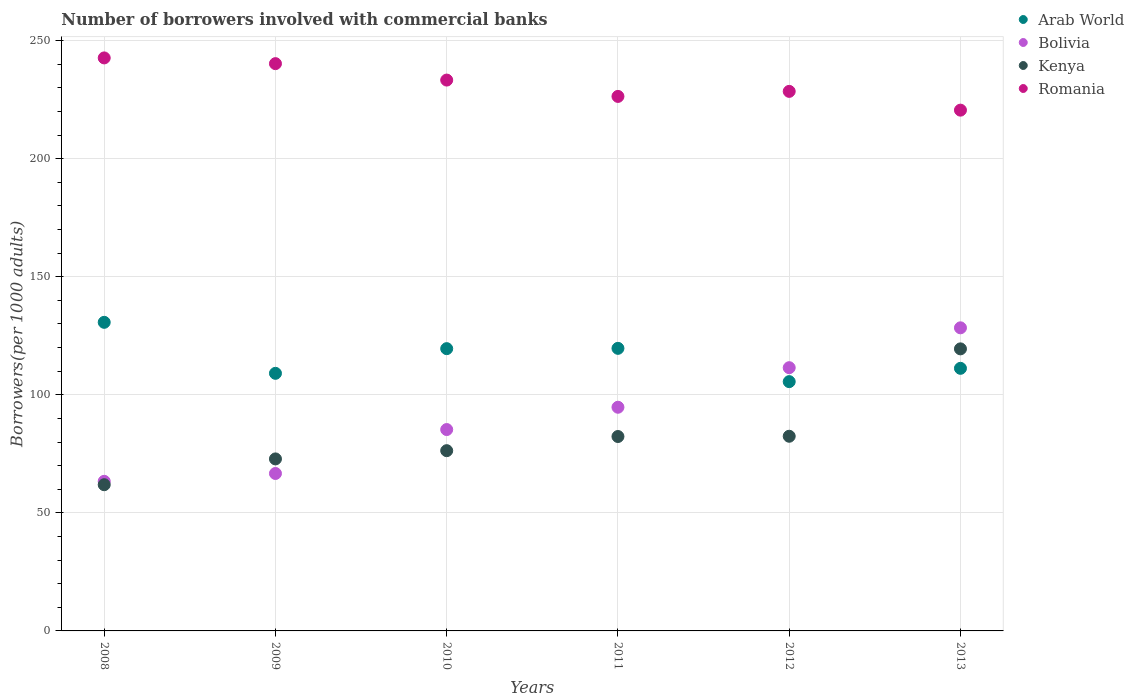How many different coloured dotlines are there?
Ensure brevity in your answer.  4. What is the number of borrowers involved with commercial banks in Arab World in 2009?
Give a very brief answer. 109.1. Across all years, what is the maximum number of borrowers involved with commercial banks in Romania?
Provide a short and direct response. 242.68. Across all years, what is the minimum number of borrowers involved with commercial banks in Romania?
Your answer should be compact. 220.56. What is the total number of borrowers involved with commercial banks in Arab World in the graph?
Offer a terse response. 695.82. What is the difference between the number of borrowers involved with commercial banks in Romania in 2010 and that in 2012?
Ensure brevity in your answer.  4.79. What is the difference between the number of borrowers involved with commercial banks in Kenya in 2011 and the number of borrowers involved with commercial banks in Romania in 2012?
Your response must be concise. -146.17. What is the average number of borrowers involved with commercial banks in Bolivia per year?
Provide a succinct answer. 91.65. In the year 2008, what is the difference between the number of borrowers involved with commercial banks in Bolivia and number of borrowers involved with commercial banks in Arab World?
Your answer should be very brief. -67.34. In how many years, is the number of borrowers involved with commercial banks in Bolivia greater than 220?
Your response must be concise. 0. What is the ratio of the number of borrowers involved with commercial banks in Bolivia in 2008 to that in 2010?
Give a very brief answer. 0.74. Is the number of borrowers involved with commercial banks in Bolivia in 2010 less than that in 2013?
Your answer should be compact. Yes. Is the difference between the number of borrowers involved with commercial banks in Bolivia in 2008 and 2013 greater than the difference between the number of borrowers involved with commercial banks in Arab World in 2008 and 2013?
Your response must be concise. No. What is the difference between the highest and the second highest number of borrowers involved with commercial banks in Bolivia?
Provide a short and direct response. 16.88. What is the difference between the highest and the lowest number of borrowers involved with commercial banks in Romania?
Your answer should be very brief. 22.12. Is it the case that in every year, the sum of the number of borrowers involved with commercial banks in Romania and number of borrowers involved with commercial banks in Bolivia  is greater than the number of borrowers involved with commercial banks in Kenya?
Offer a very short reply. Yes. Does the number of borrowers involved with commercial banks in Kenya monotonically increase over the years?
Your response must be concise. Yes. How many dotlines are there?
Your answer should be very brief. 4. Are the values on the major ticks of Y-axis written in scientific E-notation?
Provide a short and direct response. No. What is the title of the graph?
Provide a succinct answer. Number of borrowers involved with commercial banks. What is the label or title of the Y-axis?
Your response must be concise. Borrowers(per 1000 adults). What is the Borrowers(per 1000 adults) in Arab World in 2008?
Offer a terse response. 130.7. What is the Borrowers(per 1000 adults) in Bolivia in 2008?
Offer a terse response. 63.36. What is the Borrowers(per 1000 adults) of Kenya in 2008?
Provide a succinct answer. 61.92. What is the Borrowers(per 1000 adults) of Romania in 2008?
Make the answer very short. 242.68. What is the Borrowers(per 1000 adults) of Arab World in 2009?
Offer a terse response. 109.1. What is the Borrowers(per 1000 adults) in Bolivia in 2009?
Keep it short and to the point. 66.68. What is the Borrowers(per 1000 adults) of Kenya in 2009?
Provide a short and direct response. 72.85. What is the Borrowers(per 1000 adults) of Romania in 2009?
Your response must be concise. 240.26. What is the Borrowers(per 1000 adults) of Arab World in 2010?
Ensure brevity in your answer.  119.55. What is the Borrowers(per 1000 adults) in Bolivia in 2010?
Your answer should be very brief. 85.29. What is the Borrowers(per 1000 adults) of Kenya in 2010?
Offer a terse response. 76.34. What is the Borrowers(per 1000 adults) of Romania in 2010?
Offer a terse response. 233.3. What is the Borrowers(per 1000 adults) in Arab World in 2011?
Offer a terse response. 119.68. What is the Borrowers(per 1000 adults) in Bolivia in 2011?
Your answer should be very brief. 94.73. What is the Borrowers(per 1000 adults) of Kenya in 2011?
Keep it short and to the point. 82.34. What is the Borrowers(per 1000 adults) in Romania in 2011?
Your answer should be very brief. 226.38. What is the Borrowers(per 1000 adults) in Arab World in 2012?
Keep it short and to the point. 105.58. What is the Borrowers(per 1000 adults) of Bolivia in 2012?
Give a very brief answer. 111.49. What is the Borrowers(per 1000 adults) in Kenya in 2012?
Offer a terse response. 82.45. What is the Borrowers(per 1000 adults) in Romania in 2012?
Make the answer very short. 228.51. What is the Borrowers(per 1000 adults) of Arab World in 2013?
Ensure brevity in your answer.  111.22. What is the Borrowers(per 1000 adults) in Bolivia in 2013?
Provide a short and direct response. 128.37. What is the Borrowers(per 1000 adults) of Kenya in 2013?
Offer a very short reply. 119.46. What is the Borrowers(per 1000 adults) of Romania in 2013?
Your response must be concise. 220.56. Across all years, what is the maximum Borrowers(per 1000 adults) in Arab World?
Your answer should be very brief. 130.7. Across all years, what is the maximum Borrowers(per 1000 adults) in Bolivia?
Your answer should be compact. 128.37. Across all years, what is the maximum Borrowers(per 1000 adults) of Kenya?
Keep it short and to the point. 119.46. Across all years, what is the maximum Borrowers(per 1000 adults) of Romania?
Provide a succinct answer. 242.68. Across all years, what is the minimum Borrowers(per 1000 adults) in Arab World?
Your answer should be very brief. 105.58. Across all years, what is the minimum Borrowers(per 1000 adults) in Bolivia?
Your response must be concise. 63.36. Across all years, what is the minimum Borrowers(per 1000 adults) in Kenya?
Your answer should be compact. 61.92. Across all years, what is the minimum Borrowers(per 1000 adults) in Romania?
Your answer should be compact. 220.56. What is the total Borrowers(per 1000 adults) of Arab World in the graph?
Provide a short and direct response. 695.82. What is the total Borrowers(per 1000 adults) in Bolivia in the graph?
Provide a succinct answer. 549.91. What is the total Borrowers(per 1000 adults) in Kenya in the graph?
Make the answer very short. 495.36. What is the total Borrowers(per 1000 adults) of Romania in the graph?
Offer a terse response. 1391.7. What is the difference between the Borrowers(per 1000 adults) in Arab World in 2008 and that in 2009?
Your response must be concise. 21.6. What is the difference between the Borrowers(per 1000 adults) in Bolivia in 2008 and that in 2009?
Make the answer very short. -3.32. What is the difference between the Borrowers(per 1000 adults) of Kenya in 2008 and that in 2009?
Offer a very short reply. -10.93. What is the difference between the Borrowers(per 1000 adults) of Romania in 2008 and that in 2009?
Keep it short and to the point. 2.43. What is the difference between the Borrowers(per 1000 adults) in Arab World in 2008 and that in 2010?
Your answer should be very brief. 11.15. What is the difference between the Borrowers(per 1000 adults) of Bolivia in 2008 and that in 2010?
Ensure brevity in your answer.  -21.93. What is the difference between the Borrowers(per 1000 adults) of Kenya in 2008 and that in 2010?
Provide a succinct answer. -14.42. What is the difference between the Borrowers(per 1000 adults) of Romania in 2008 and that in 2010?
Your answer should be very brief. 9.38. What is the difference between the Borrowers(per 1000 adults) in Arab World in 2008 and that in 2011?
Offer a very short reply. 11.02. What is the difference between the Borrowers(per 1000 adults) in Bolivia in 2008 and that in 2011?
Offer a terse response. -31.37. What is the difference between the Borrowers(per 1000 adults) of Kenya in 2008 and that in 2011?
Provide a succinct answer. -20.41. What is the difference between the Borrowers(per 1000 adults) of Romania in 2008 and that in 2011?
Your answer should be very brief. 16.31. What is the difference between the Borrowers(per 1000 adults) of Arab World in 2008 and that in 2012?
Ensure brevity in your answer.  25.12. What is the difference between the Borrowers(per 1000 adults) in Bolivia in 2008 and that in 2012?
Offer a terse response. -48.13. What is the difference between the Borrowers(per 1000 adults) in Kenya in 2008 and that in 2012?
Provide a short and direct response. -20.52. What is the difference between the Borrowers(per 1000 adults) of Romania in 2008 and that in 2012?
Your answer should be very brief. 14.17. What is the difference between the Borrowers(per 1000 adults) in Arab World in 2008 and that in 2013?
Your answer should be compact. 19.48. What is the difference between the Borrowers(per 1000 adults) in Bolivia in 2008 and that in 2013?
Give a very brief answer. -65.01. What is the difference between the Borrowers(per 1000 adults) in Kenya in 2008 and that in 2013?
Your response must be concise. -57.54. What is the difference between the Borrowers(per 1000 adults) of Romania in 2008 and that in 2013?
Offer a very short reply. 22.12. What is the difference between the Borrowers(per 1000 adults) in Arab World in 2009 and that in 2010?
Your response must be concise. -10.45. What is the difference between the Borrowers(per 1000 adults) in Bolivia in 2009 and that in 2010?
Provide a short and direct response. -18.61. What is the difference between the Borrowers(per 1000 adults) of Kenya in 2009 and that in 2010?
Provide a succinct answer. -3.49. What is the difference between the Borrowers(per 1000 adults) of Romania in 2009 and that in 2010?
Your answer should be compact. 6.96. What is the difference between the Borrowers(per 1000 adults) of Arab World in 2009 and that in 2011?
Offer a very short reply. -10.58. What is the difference between the Borrowers(per 1000 adults) in Bolivia in 2009 and that in 2011?
Your response must be concise. -28.05. What is the difference between the Borrowers(per 1000 adults) of Kenya in 2009 and that in 2011?
Provide a succinct answer. -9.49. What is the difference between the Borrowers(per 1000 adults) in Romania in 2009 and that in 2011?
Your response must be concise. 13.88. What is the difference between the Borrowers(per 1000 adults) in Arab World in 2009 and that in 2012?
Provide a succinct answer. 3.52. What is the difference between the Borrowers(per 1000 adults) of Bolivia in 2009 and that in 2012?
Give a very brief answer. -44.81. What is the difference between the Borrowers(per 1000 adults) in Kenya in 2009 and that in 2012?
Ensure brevity in your answer.  -9.6. What is the difference between the Borrowers(per 1000 adults) in Romania in 2009 and that in 2012?
Make the answer very short. 11.75. What is the difference between the Borrowers(per 1000 adults) in Arab World in 2009 and that in 2013?
Your answer should be compact. -2.12. What is the difference between the Borrowers(per 1000 adults) in Bolivia in 2009 and that in 2013?
Offer a terse response. -61.69. What is the difference between the Borrowers(per 1000 adults) of Kenya in 2009 and that in 2013?
Give a very brief answer. -46.61. What is the difference between the Borrowers(per 1000 adults) of Romania in 2009 and that in 2013?
Provide a succinct answer. 19.7. What is the difference between the Borrowers(per 1000 adults) in Arab World in 2010 and that in 2011?
Keep it short and to the point. -0.13. What is the difference between the Borrowers(per 1000 adults) in Bolivia in 2010 and that in 2011?
Offer a terse response. -9.45. What is the difference between the Borrowers(per 1000 adults) of Kenya in 2010 and that in 2011?
Make the answer very short. -6. What is the difference between the Borrowers(per 1000 adults) in Romania in 2010 and that in 2011?
Provide a succinct answer. 6.92. What is the difference between the Borrowers(per 1000 adults) of Arab World in 2010 and that in 2012?
Provide a succinct answer. 13.97. What is the difference between the Borrowers(per 1000 adults) in Bolivia in 2010 and that in 2012?
Make the answer very short. -26.2. What is the difference between the Borrowers(per 1000 adults) in Kenya in 2010 and that in 2012?
Provide a succinct answer. -6.11. What is the difference between the Borrowers(per 1000 adults) in Romania in 2010 and that in 2012?
Offer a very short reply. 4.79. What is the difference between the Borrowers(per 1000 adults) of Arab World in 2010 and that in 2013?
Make the answer very short. 8.33. What is the difference between the Borrowers(per 1000 adults) in Bolivia in 2010 and that in 2013?
Provide a short and direct response. -43.08. What is the difference between the Borrowers(per 1000 adults) in Kenya in 2010 and that in 2013?
Your answer should be compact. -43.12. What is the difference between the Borrowers(per 1000 adults) of Romania in 2010 and that in 2013?
Give a very brief answer. 12.74. What is the difference between the Borrowers(per 1000 adults) of Arab World in 2011 and that in 2012?
Provide a short and direct response. 14.1. What is the difference between the Borrowers(per 1000 adults) of Bolivia in 2011 and that in 2012?
Make the answer very short. -16.75. What is the difference between the Borrowers(per 1000 adults) in Kenya in 2011 and that in 2012?
Provide a short and direct response. -0.11. What is the difference between the Borrowers(per 1000 adults) of Romania in 2011 and that in 2012?
Keep it short and to the point. -2.13. What is the difference between the Borrowers(per 1000 adults) in Arab World in 2011 and that in 2013?
Ensure brevity in your answer.  8.46. What is the difference between the Borrowers(per 1000 adults) in Bolivia in 2011 and that in 2013?
Offer a very short reply. -33.64. What is the difference between the Borrowers(per 1000 adults) in Kenya in 2011 and that in 2013?
Offer a terse response. -37.12. What is the difference between the Borrowers(per 1000 adults) in Romania in 2011 and that in 2013?
Give a very brief answer. 5.82. What is the difference between the Borrowers(per 1000 adults) of Arab World in 2012 and that in 2013?
Make the answer very short. -5.64. What is the difference between the Borrowers(per 1000 adults) of Bolivia in 2012 and that in 2013?
Your answer should be very brief. -16.88. What is the difference between the Borrowers(per 1000 adults) of Kenya in 2012 and that in 2013?
Make the answer very short. -37.01. What is the difference between the Borrowers(per 1000 adults) of Romania in 2012 and that in 2013?
Provide a short and direct response. 7.95. What is the difference between the Borrowers(per 1000 adults) of Arab World in 2008 and the Borrowers(per 1000 adults) of Bolivia in 2009?
Your answer should be very brief. 64.02. What is the difference between the Borrowers(per 1000 adults) in Arab World in 2008 and the Borrowers(per 1000 adults) in Kenya in 2009?
Ensure brevity in your answer.  57.85. What is the difference between the Borrowers(per 1000 adults) in Arab World in 2008 and the Borrowers(per 1000 adults) in Romania in 2009?
Provide a short and direct response. -109.56. What is the difference between the Borrowers(per 1000 adults) of Bolivia in 2008 and the Borrowers(per 1000 adults) of Kenya in 2009?
Your response must be concise. -9.49. What is the difference between the Borrowers(per 1000 adults) in Bolivia in 2008 and the Borrowers(per 1000 adults) in Romania in 2009?
Provide a succinct answer. -176.9. What is the difference between the Borrowers(per 1000 adults) of Kenya in 2008 and the Borrowers(per 1000 adults) of Romania in 2009?
Make the answer very short. -178.34. What is the difference between the Borrowers(per 1000 adults) of Arab World in 2008 and the Borrowers(per 1000 adults) of Bolivia in 2010?
Make the answer very short. 45.41. What is the difference between the Borrowers(per 1000 adults) of Arab World in 2008 and the Borrowers(per 1000 adults) of Kenya in 2010?
Make the answer very short. 54.36. What is the difference between the Borrowers(per 1000 adults) of Arab World in 2008 and the Borrowers(per 1000 adults) of Romania in 2010?
Provide a succinct answer. -102.6. What is the difference between the Borrowers(per 1000 adults) in Bolivia in 2008 and the Borrowers(per 1000 adults) in Kenya in 2010?
Provide a succinct answer. -12.98. What is the difference between the Borrowers(per 1000 adults) of Bolivia in 2008 and the Borrowers(per 1000 adults) of Romania in 2010?
Make the answer very short. -169.94. What is the difference between the Borrowers(per 1000 adults) of Kenya in 2008 and the Borrowers(per 1000 adults) of Romania in 2010?
Offer a very short reply. -171.38. What is the difference between the Borrowers(per 1000 adults) in Arab World in 2008 and the Borrowers(per 1000 adults) in Bolivia in 2011?
Offer a terse response. 35.97. What is the difference between the Borrowers(per 1000 adults) of Arab World in 2008 and the Borrowers(per 1000 adults) of Kenya in 2011?
Offer a terse response. 48.36. What is the difference between the Borrowers(per 1000 adults) of Arab World in 2008 and the Borrowers(per 1000 adults) of Romania in 2011?
Provide a succinct answer. -95.68. What is the difference between the Borrowers(per 1000 adults) in Bolivia in 2008 and the Borrowers(per 1000 adults) in Kenya in 2011?
Give a very brief answer. -18.98. What is the difference between the Borrowers(per 1000 adults) of Bolivia in 2008 and the Borrowers(per 1000 adults) of Romania in 2011?
Give a very brief answer. -163.02. What is the difference between the Borrowers(per 1000 adults) of Kenya in 2008 and the Borrowers(per 1000 adults) of Romania in 2011?
Offer a terse response. -164.46. What is the difference between the Borrowers(per 1000 adults) of Arab World in 2008 and the Borrowers(per 1000 adults) of Bolivia in 2012?
Ensure brevity in your answer.  19.21. What is the difference between the Borrowers(per 1000 adults) of Arab World in 2008 and the Borrowers(per 1000 adults) of Kenya in 2012?
Your answer should be compact. 48.25. What is the difference between the Borrowers(per 1000 adults) in Arab World in 2008 and the Borrowers(per 1000 adults) in Romania in 2012?
Your answer should be very brief. -97.81. What is the difference between the Borrowers(per 1000 adults) in Bolivia in 2008 and the Borrowers(per 1000 adults) in Kenya in 2012?
Provide a succinct answer. -19.09. What is the difference between the Borrowers(per 1000 adults) of Bolivia in 2008 and the Borrowers(per 1000 adults) of Romania in 2012?
Offer a terse response. -165.15. What is the difference between the Borrowers(per 1000 adults) in Kenya in 2008 and the Borrowers(per 1000 adults) in Romania in 2012?
Offer a very short reply. -166.59. What is the difference between the Borrowers(per 1000 adults) in Arab World in 2008 and the Borrowers(per 1000 adults) in Bolivia in 2013?
Ensure brevity in your answer.  2.33. What is the difference between the Borrowers(per 1000 adults) in Arab World in 2008 and the Borrowers(per 1000 adults) in Kenya in 2013?
Offer a terse response. 11.24. What is the difference between the Borrowers(per 1000 adults) in Arab World in 2008 and the Borrowers(per 1000 adults) in Romania in 2013?
Provide a succinct answer. -89.87. What is the difference between the Borrowers(per 1000 adults) in Bolivia in 2008 and the Borrowers(per 1000 adults) in Kenya in 2013?
Your answer should be very brief. -56.1. What is the difference between the Borrowers(per 1000 adults) in Bolivia in 2008 and the Borrowers(per 1000 adults) in Romania in 2013?
Ensure brevity in your answer.  -157.2. What is the difference between the Borrowers(per 1000 adults) of Kenya in 2008 and the Borrowers(per 1000 adults) of Romania in 2013?
Your response must be concise. -158.64. What is the difference between the Borrowers(per 1000 adults) of Arab World in 2009 and the Borrowers(per 1000 adults) of Bolivia in 2010?
Your answer should be very brief. 23.81. What is the difference between the Borrowers(per 1000 adults) in Arab World in 2009 and the Borrowers(per 1000 adults) in Kenya in 2010?
Your response must be concise. 32.76. What is the difference between the Borrowers(per 1000 adults) in Arab World in 2009 and the Borrowers(per 1000 adults) in Romania in 2010?
Offer a very short reply. -124.2. What is the difference between the Borrowers(per 1000 adults) in Bolivia in 2009 and the Borrowers(per 1000 adults) in Kenya in 2010?
Make the answer very short. -9.66. What is the difference between the Borrowers(per 1000 adults) of Bolivia in 2009 and the Borrowers(per 1000 adults) of Romania in 2010?
Keep it short and to the point. -166.62. What is the difference between the Borrowers(per 1000 adults) in Kenya in 2009 and the Borrowers(per 1000 adults) in Romania in 2010?
Ensure brevity in your answer.  -160.45. What is the difference between the Borrowers(per 1000 adults) in Arab World in 2009 and the Borrowers(per 1000 adults) in Bolivia in 2011?
Your answer should be compact. 14.37. What is the difference between the Borrowers(per 1000 adults) in Arab World in 2009 and the Borrowers(per 1000 adults) in Kenya in 2011?
Your response must be concise. 26.76. What is the difference between the Borrowers(per 1000 adults) of Arab World in 2009 and the Borrowers(per 1000 adults) of Romania in 2011?
Make the answer very short. -117.28. What is the difference between the Borrowers(per 1000 adults) of Bolivia in 2009 and the Borrowers(per 1000 adults) of Kenya in 2011?
Your response must be concise. -15.66. What is the difference between the Borrowers(per 1000 adults) of Bolivia in 2009 and the Borrowers(per 1000 adults) of Romania in 2011?
Keep it short and to the point. -159.7. What is the difference between the Borrowers(per 1000 adults) in Kenya in 2009 and the Borrowers(per 1000 adults) in Romania in 2011?
Your answer should be compact. -153.53. What is the difference between the Borrowers(per 1000 adults) in Arab World in 2009 and the Borrowers(per 1000 adults) in Bolivia in 2012?
Provide a short and direct response. -2.39. What is the difference between the Borrowers(per 1000 adults) of Arab World in 2009 and the Borrowers(per 1000 adults) of Kenya in 2012?
Give a very brief answer. 26.65. What is the difference between the Borrowers(per 1000 adults) of Arab World in 2009 and the Borrowers(per 1000 adults) of Romania in 2012?
Provide a succinct answer. -119.41. What is the difference between the Borrowers(per 1000 adults) in Bolivia in 2009 and the Borrowers(per 1000 adults) in Kenya in 2012?
Your answer should be very brief. -15.77. What is the difference between the Borrowers(per 1000 adults) in Bolivia in 2009 and the Borrowers(per 1000 adults) in Romania in 2012?
Provide a succinct answer. -161.83. What is the difference between the Borrowers(per 1000 adults) of Kenya in 2009 and the Borrowers(per 1000 adults) of Romania in 2012?
Make the answer very short. -155.66. What is the difference between the Borrowers(per 1000 adults) of Arab World in 2009 and the Borrowers(per 1000 adults) of Bolivia in 2013?
Ensure brevity in your answer.  -19.27. What is the difference between the Borrowers(per 1000 adults) in Arab World in 2009 and the Borrowers(per 1000 adults) in Kenya in 2013?
Offer a very short reply. -10.36. What is the difference between the Borrowers(per 1000 adults) in Arab World in 2009 and the Borrowers(per 1000 adults) in Romania in 2013?
Offer a terse response. -111.47. What is the difference between the Borrowers(per 1000 adults) in Bolivia in 2009 and the Borrowers(per 1000 adults) in Kenya in 2013?
Make the answer very short. -52.78. What is the difference between the Borrowers(per 1000 adults) in Bolivia in 2009 and the Borrowers(per 1000 adults) in Romania in 2013?
Your response must be concise. -153.88. What is the difference between the Borrowers(per 1000 adults) of Kenya in 2009 and the Borrowers(per 1000 adults) of Romania in 2013?
Give a very brief answer. -147.71. What is the difference between the Borrowers(per 1000 adults) in Arab World in 2010 and the Borrowers(per 1000 adults) in Bolivia in 2011?
Your answer should be very brief. 24.82. What is the difference between the Borrowers(per 1000 adults) of Arab World in 2010 and the Borrowers(per 1000 adults) of Kenya in 2011?
Your answer should be compact. 37.21. What is the difference between the Borrowers(per 1000 adults) of Arab World in 2010 and the Borrowers(per 1000 adults) of Romania in 2011?
Offer a very short reply. -106.83. What is the difference between the Borrowers(per 1000 adults) in Bolivia in 2010 and the Borrowers(per 1000 adults) in Kenya in 2011?
Keep it short and to the point. 2.95. What is the difference between the Borrowers(per 1000 adults) of Bolivia in 2010 and the Borrowers(per 1000 adults) of Romania in 2011?
Your answer should be very brief. -141.09. What is the difference between the Borrowers(per 1000 adults) in Kenya in 2010 and the Borrowers(per 1000 adults) in Romania in 2011?
Offer a terse response. -150.04. What is the difference between the Borrowers(per 1000 adults) of Arab World in 2010 and the Borrowers(per 1000 adults) of Bolivia in 2012?
Your response must be concise. 8.06. What is the difference between the Borrowers(per 1000 adults) in Arab World in 2010 and the Borrowers(per 1000 adults) in Kenya in 2012?
Ensure brevity in your answer.  37.1. What is the difference between the Borrowers(per 1000 adults) in Arab World in 2010 and the Borrowers(per 1000 adults) in Romania in 2012?
Keep it short and to the point. -108.96. What is the difference between the Borrowers(per 1000 adults) of Bolivia in 2010 and the Borrowers(per 1000 adults) of Kenya in 2012?
Offer a terse response. 2.84. What is the difference between the Borrowers(per 1000 adults) in Bolivia in 2010 and the Borrowers(per 1000 adults) in Romania in 2012?
Your answer should be very brief. -143.23. What is the difference between the Borrowers(per 1000 adults) of Kenya in 2010 and the Borrowers(per 1000 adults) of Romania in 2012?
Give a very brief answer. -152.17. What is the difference between the Borrowers(per 1000 adults) in Arab World in 2010 and the Borrowers(per 1000 adults) in Bolivia in 2013?
Your response must be concise. -8.82. What is the difference between the Borrowers(per 1000 adults) of Arab World in 2010 and the Borrowers(per 1000 adults) of Kenya in 2013?
Your response must be concise. 0.09. What is the difference between the Borrowers(per 1000 adults) in Arab World in 2010 and the Borrowers(per 1000 adults) in Romania in 2013?
Your response must be concise. -101.01. What is the difference between the Borrowers(per 1000 adults) in Bolivia in 2010 and the Borrowers(per 1000 adults) in Kenya in 2013?
Your answer should be compact. -34.17. What is the difference between the Borrowers(per 1000 adults) in Bolivia in 2010 and the Borrowers(per 1000 adults) in Romania in 2013?
Make the answer very short. -135.28. What is the difference between the Borrowers(per 1000 adults) of Kenya in 2010 and the Borrowers(per 1000 adults) of Romania in 2013?
Provide a succinct answer. -144.22. What is the difference between the Borrowers(per 1000 adults) of Arab World in 2011 and the Borrowers(per 1000 adults) of Bolivia in 2012?
Make the answer very short. 8.19. What is the difference between the Borrowers(per 1000 adults) in Arab World in 2011 and the Borrowers(per 1000 adults) in Kenya in 2012?
Give a very brief answer. 37.23. What is the difference between the Borrowers(per 1000 adults) in Arab World in 2011 and the Borrowers(per 1000 adults) in Romania in 2012?
Keep it short and to the point. -108.83. What is the difference between the Borrowers(per 1000 adults) of Bolivia in 2011 and the Borrowers(per 1000 adults) of Kenya in 2012?
Make the answer very short. 12.28. What is the difference between the Borrowers(per 1000 adults) in Bolivia in 2011 and the Borrowers(per 1000 adults) in Romania in 2012?
Offer a terse response. -133.78. What is the difference between the Borrowers(per 1000 adults) of Kenya in 2011 and the Borrowers(per 1000 adults) of Romania in 2012?
Your response must be concise. -146.17. What is the difference between the Borrowers(per 1000 adults) of Arab World in 2011 and the Borrowers(per 1000 adults) of Bolivia in 2013?
Your answer should be compact. -8.69. What is the difference between the Borrowers(per 1000 adults) in Arab World in 2011 and the Borrowers(per 1000 adults) in Kenya in 2013?
Provide a short and direct response. 0.22. What is the difference between the Borrowers(per 1000 adults) in Arab World in 2011 and the Borrowers(per 1000 adults) in Romania in 2013?
Offer a very short reply. -100.88. What is the difference between the Borrowers(per 1000 adults) in Bolivia in 2011 and the Borrowers(per 1000 adults) in Kenya in 2013?
Keep it short and to the point. -24.73. What is the difference between the Borrowers(per 1000 adults) of Bolivia in 2011 and the Borrowers(per 1000 adults) of Romania in 2013?
Offer a terse response. -125.83. What is the difference between the Borrowers(per 1000 adults) of Kenya in 2011 and the Borrowers(per 1000 adults) of Romania in 2013?
Provide a short and direct response. -138.23. What is the difference between the Borrowers(per 1000 adults) in Arab World in 2012 and the Borrowers(per 1000 adults) in Bolivia in 2013?
Provide a short and direct response. -22.79. What is the difference between the Borrowers(per 1000 adults) in Arab World in 2012 and the Borrowers(per 1000 adults) in Kenya in 2013?
Offer a terse response. -13.88. What is the difference between the Borrowers(per 1000 adults) of Arab World in 2012 and the Borrowers(per 1000 adults) of Romania in 2013?
Your answer should be very brief. -114.98. What is the difference between the Borrowers(per 1000 adults) in Bolivia in 2012 and the Borrowers(per 1000 adults) in Kenya in 2013?
Give a very brief answer. -7.97. What is the difference between the Borrowers(per 1000 adults) in Bolivia in 2012 and the Borrowers(per 1000 adults) in Romania in 2013?
Give a very brief answer. -109.08. What is the difference between the Borrowers(per 1000 adults) of Kenya in 2012 and the Borrowers(per 1000 adults) of Romania in 2013?
Give a very brief answer. -138.12. What is the average Borrowers(per 1000 adults) of Arab World per year?
Offer a very short reply. 115.97. What is the average Borrowers(per 1000 adults) in Bolivia per year?
Your answer should be very brief. 91.65. What is the average Borrowers(per 1000 adults) in Kenya per year?
Ensure brevity in your answer.  82.56. What is the average Borrowers(per 1000 adults) in Romania per year?
Keep it short and to the point. 231.95. In the year 2008, what is the difference between the Borrowers(per 1000 adults) of Arab World and Borrowers(per 1000 adults) of Bolivia?
Make the answer very short. 67.34. In the year 2008, what is the difference between the Borrowers(per 1000 adults) of Arab World and Borrowers(per 1000 adults) of Kenya?
Provide a succinct answer. 68.77. In the year 2008, what is the difference between the Borrowers(per 1000 adults) in Arab World and Borrowers(per 1000 adults) in Romania?
Your answer should be compact. -111.99. In the year 2008, what is the difference between the Borrowers(per 1000 adults) of Bolivia and Borrowers(per 1000 adults) of Kenya?
Give a very brief answer. 1.43. In the year 2008, what is the difference between the Borrowers(per 1000 adults) of Bolivia and Borrowers(per 1000 adults) of Romania?
Your response must be concise. -179.33. In the year 2008, what is the difference between the Borrowers(per 1000 adults) in Kenya and Borrowers(per 1000 adults) in Romania?
Your response must be concise. -180.76. In the year 2009, what is the difference between the Borrowers(per 1000 adults) in Arab World and Borrowers(per 1000 adults) in Bolivia?
Your answer should be compact. 42.42. In the year 2009, what is the difference between the Borrowers(per 1000 adults) of Arab World and Borrowers(per 1000 adults) of Kenya?
Make the answer very short. 36.25. In the year 2009, what is the difference between the Borrowers(per 1000 adults) in Arab World and Borrowers(per 1000 adults) in Romania?
Your answer should be very brief. -131.16. In the year 2009, what is the difference between the Borrowers(per 1000 adults) of Bolivia and Borrowers(per 1000 adults) of Kenya?
Your answer should be very brief. -6.17. In the year 2009, what is the difference between the Borrowers(per 1000 adults) of Bolivia and Borrowers(per 1000 adults) of Romania?
Your response must be concise. -173.58. In the year 2009, what is the difference between the Borrowers(per 1000 adults) in Kenya and Borrowers(per 1000 adults) in Romania?
Your response must be concise. -167.41. In the year 2010, what is the difference between the Borrowers(per 1000 adults) of Arab World and Borrowers(per 1000 adults) of Bolivia?
Offer a very short reply. 34.26. In the year 2010, what is the difference between the Borrowers(per 1000 adults) of Arab World and Borrowers(per 1000 adults) of Kenya?
Give a very brief answer. 43.21. In the year 2010, what is the difference between the Borrowers(per 1000 adults) of Arab World and Borrowers(per 1000 adults) of Romania?
Your answer should be very brief. -113.75. In the year 2010, what is the difference between the Borrowers(per 1000 adults) in Bolivia and Borrowers(per 1000 adults) in Kenya?
Offer a very short reply. 8.95. In the year 2010, what is the difference between the Borrowers(per 1000 adults) in Bolivia and Borrowers(per 1000 adults) in Romania?
Your answer should be compact. -148.01. In the year 2010, what is the difference between the Borrowers(per 1000 adults) of Kenya and Borrowers(per 1000 adults) of Romania?
Give a very brief answer. -156.96. In the year 2011, what is the difference between the Borrowers(per 1000 adults) in Arab World and Borrowers(per 1000 adults) in Bolivia?
Provide a succinct answer. 24.95. In the year 2011, what is the difference between the Borrowers(per 1000 adults) of Arab World and Borrowers(per 1000 adults) of Kenya?
Provide a succinct answer. 37.34. In the year 2011, what is the difference between the Borrowers(per 1000 adults) in Arab World and Borrowers(per 1000 adults) in Romania?
Offer a terse response. -106.7. In the year 2011, what is the difference between the Borrowers(per 1000 adults) of Bolivia and Borrowers(per 1000 adults) of Kenya?
Provide a short and direct response. 12.39. In the year 2011, what is the difference between the Borrowers(per 1000 adults) in Bolivia and Borrowers(per 1000 adults) in Romania?
Ensure brevity in your answer.  -131.65. In the year 2011, what is the difference between the Borrowers(per 1000 adults) of Kenya and Borrowers(per 1000 adults) of Romania?
Your answer should be compact. -144.04. In the year 2012, what is the difference between the Borrowers(per 1000 adults) of Arab World and Borrowers(per 1000 adults) of Bolivia?
Keep it short and to the point. -5.91. In the year 2012, what is the difference between the Borrowers(per 1000 adults) in Arab World and Borrowers(per 1000 adults) in Kenya?
Keep it short and to the point. 23.13. In the year 2012, what is the difference between the Borrowers(per 1000 adults) in Arab World and Borrowers(per 1000 adults) in Romania?
Offer a very short reply. -122.93. In the year 2012, what is the difference between the Borrowers(per 1000 adults) of Bolivia and Borrowers(per 1000 adults) of Kenya?
Your answer should be compact. 29.04. In the year 2012, what is the difference between the Borrowers(per 1000 adults) of Bolivia and Borrowers(per 1000 adults) of Romania?
Give a very brief answer. -117.03. In the year 2012, what is the difference between the Borrowers(per 1000 adults) in Kenya and Borrowers(per 1000 adults) in Romania?
Provide a short and direct response. -146.06. In the year 2013, what is the difference between the Borrowers(per 1000 adults) in Arab World and Borrowers(per 1000 adults) in Bolivia?
Offer a very short reply. -17.15. In the year 2013, what is the difference between the Borrowers(per 1000 adults) of Arab World and Borrowers(per 1000 adults) of Kenya?
Give a very brief answer. -8.24. In the year 2013, what is the difference between the Borrowers(per 1000 adults) in Arab World and Borrowers(per 1000 adults) in Romania?
Provide a short and direct response. -109.35. In the year 2013, what is the difference between the Borrowers(per 1000 adults) in Bolivia and Borrowers(per 1000 adults) in Kenya?
Your answer should be very brief. 8.91. In the year 2013, what is the difference between the Borrowers(per 1000 adults) of Bolivia and Borrowers(per 1000 adults) of Romania?
Your response must be concise. -92.19. In the year 2013, what is the difference between the Borrowers(per 1000 adults) of Kenya and Borrowers(per 1000 adults) of Romania?
Offer a terse response. -101.1. What is the ratio of the Borrowers(per 1000 adults) in Arab World in 2008 to that in 2009?
Your answer should be compact. 1.2. What is the ratio of the Borrowers(per 1000 adults) of Bolivia in 2008 to that in 2009?
Offer a very short reply. 0.95. What is the ratio of the Borrowers(per 1000 adults) in Romania in 2008 to that in 2009?
Provide a succinct answer. 1.01. What is the ratio of the Borrowers(per 1000 adults) of Arab World in 2008 to that in 2010?
Provide a short and direct response. 1.09. What is the ratio of the Borrowers(per 1000 adults) in Bolivia in 2008 to that in 2010?
Give a very brief answer. 0.74. What is the ratio of the Borrowers(per 1000 adults) in Kenya in 2008 to that in 2010?
Provide a short and direct response. 0.81. What is the ratio of the Borrowers(per 1000 adults) in Romania in 2008 to that in 2010?
Offer a terse response. 1.04. What is the ratio of the Borrowers(per 1000 adults) of Arab World in 2008 to that in 2011?
Offer a terse response. 1.09. What is the ratio of the Borrowers(per 1000 adults) in Bolivia in 2008 to that in 2011?
Provide a short and direct response. 0.67. What is the ratio of the Borrowers(per 1000 adults) in Kenya in 2008 to that in 2011?
Offer a very short reply. 0.75. What is the ratio of the Borrowers(per 1000 adults) of Romania in 2008 to that in 2011?
Your answer should be compact. 1.07. What is the ratio of the Borrowers(per 1000 adults) in Arab World in 2008 to that in 2012?
Your response must be concise. 1.24. What is the ratio of the Borrowers(per 1000 adults) in Bolivia in 2008 to that in 2012?
Make the answer very short. 0.57. What is the ratio of the Borrowers(per 1000 adults) of Kenya in 2008 to that in 2012?
Your answer should be compact. 0.75. What is the ratio of the Borrowers(per 1000 adults) of Romania in 2008 to that in 2012?
Ensure brevity in your answer.  1.06. What is the ratio of the Borrowers(per 1000 adults) in Arab World in 2008 to that in 2013?
Give a very brief answer. 1.18. What is the ratio of the Borrowers(per 1000 adults) in Bolivia in 2008 to that in 2013?
Offer a terse response. 0.49. What is the ratio of the Borrowers(per 1000 adults) of Kenya in 2008 to that in 2013?
Provide a succinct answer. 0.52. What is the ratio of the Borrowers(per 1000 adults) in Romania in 2008 to that in 2013?
Your answer should be compact. 1.1. What is the ratio of the Borrowers(per 1000 adults) of Arab World in 2009 to that in 2010?
Keep it short and to the point. 0.91. What is the ratio of the Borrowers(per 1000 adults) of Bolivia in 2009 to that in 2010?
Your answer should be compact. 0.78. What is the ratio of the Borrowers(per 1000 adults) of Kenya in 2009 to that in 2010?
Offer a very short reply. 0.95. What is the ratio of the Borrowers(per 1000 adults) in Romania in 2009 to that in 2010?
Your answer should be very brief. 1.03. What is the ratio of the Borrowers(per 1000 adults) of Arab World in 2009 to that in 2011?
Offer a terse response. 0.91. What is the ratio of the Borrowers(per 1000 adults) of Bolivia in 2009 to that in 2011?
Ensure brevity in your answer.  0.7. What is the ratio of the Borrowers(per 1000 adults) of Kenya in 2009 to that in 2011?
Offer a terse response. 0.88. What is the ratio of the Borrowers(per 1000 adults) in Romania in 2009 to that in 2011?
Your response must be concise. 1.06. What is the ratio of the Borrowers(per 1000 adults) of Bolivia in 2009 to that in 2012?
Provide a short and direct response. 0.6. What is the ratio of the Borrowers(per 1000 adults) of Kenya in 2009 to that in 2012?
Ensure brevity in your answer.  0.88. What is the ratio of the Borrowers(per 1000 adults) in Romania in 2009 to that in 2012?
Offer a very short reply. 1.05. What is the ratio of the Borrowers(per 1000 adults) of Bolivia in 2009 to that in 2013?
Give a very brief answer. 0.52. What is the ratio of the Borrowers(per 1000 adults) in Kenya in 2009 to that in 2013?
Ensure brevity in your answer.  0.61. What is the ratio of the Borrowers(per 1000 adults) in Romania in 2009 to that in 2013?
Offer a terse response. 1.09. What is the ratio of the Borrowers(per 1000 adults) in Arab World in 2010 to that in 2011?
Offer a very short reply. 1. What is the ratio of the Borrowers(per 1000 adults) of Bolivia in 2010 to that in 2011?
Your response must be concise. 0.9. What is the ratio of the Borrowers(per 1000 adults) in Kenya in 2010 to that in 2011?
Your response must be concise. 0.93. What is the ratio of the Borrowers(per 1000 adults) of Romania in 2010 to that in 2011?
Keep it short and to the point. 1.03. What is the ratio of the Borrowers(per 1000 adults) in Arab World in 2010 to that in 2012?
Your answer should be very brief. 1.13. What is the ratio of the Borrowers(per 1000 adults) in Bolivia in 2010 to that in 2012?
Make the answer very short. 0.77. What is the ratio of the Borrowers(per 1000 adults) in Kenya in 2010 to that in 2012?
Give a very brief answer. 0.93. What is the ratio of the Borrowers(per 1000 adults) of Romania in 2010 to that in 2012?
Your answer should be compact. 1.02. What is the ratio of the Borrowers(per 1000 adults) in Arab World in 2010 to that in 2013?
Offer a very short reply. 1.07. What is the ratio of the Borrowers(per 1000 adults) in Bolivia in 2010 to that in 2013?
Provide a succinct answer. 0.66. What is the ratio of the Borrowers(per 1000 adults) of Kenya in 2010 to that in 2013?
Ensure brevity in your answer.  0.64. What is the ratio of the Borrowers(per 1000 adults) of Romania in 2010 to that in 2013?
Your answer should be compact. 1.06. What is the ratio of the Borrowers(per 1000 adults) in Arab World in 2011 to that in 2012?
Keep it short and to the point. 1.13. What is the ratio of the Borrowers(per 1000 adults) of Bolivia in 2011 to that in 2012?
Make the answer very short. 0.85. What is the ratio of the Borrowers(per 1000 adults) of Romania in 2011 to that in 2012?
Offer a very short reply. 0.99. What is the ratio of the Borrowers(per 1000 adults) in Arab World in 2011 to that in 2013?
Give a very brief answer. 1.08. What is the ratio of the Borrowers(per 1000 adults) of Bolivia in 2011 to that in 2013?
Provide a succinct answer. 0.74. What is the ratio of the Borrowers(per 1000 adults) of Kenya in 2011 to that in 2013?
Make the answer very short. 0.69. What is the ratio of the Borrowers(per 1000 adults) of Romania in 2011 to that in 2013?
Ensure brevity in your answer.  1.03. What is the ratio of the Borrowers(per 1000 adults) of Arab World in 2012 to that in 2013?
Ensure brevity in your answer.  0.95. What is the ratio of the Borrowers(per 1000 adults) of Bolivia in 2012 to that in 2013?
Provide a succinct answer. 0.87. What is the ratio of the Borrowers(per 1000 adults) in Kenya in 2012 to that in 2013?
Provide a succinct answer. 0.69. What is the ratio of the Borrowers(per 1000 adults) of Romania in 2012 to that in 2013?
Offer a terse response. 1.04. What is the difference between the highest and the second highest Borrowers(per 1000 adults) in Arab World?
Provide a short and direct response. 11.02. What is the difference between the highest and the second highest Borrowers(per 1000 adults) of Bolivia?
Offer a terse response. 16.88. What is the difference between the highest and the second highest Borrowers(per 1000 adults) of Kenya?
Provide a short and direct response. 37.01. What is the difference between the highest and the second highest Borrowers(per 1000 adults) in Romania?
Keep it short and to the point. 2.43. What is the difference between the highest and the lowest Borrowers(per 1000 adults) in Arab World?
Offer a very short reply. 25.12. What is the difference between the highest and the lowest Borrowers(per 1000 adults) in Bolivia?
Give a very brief answer. 65.01. What is the difference between the highest and the lowest Borrowers(per 1000 adults) in Kenya?
Provide a short and direct response. 57.54. What is the difference between the highest and the lowest Borrowers(per 1000 adults) in Romania?
Keep it short and to the point. 22.12. 